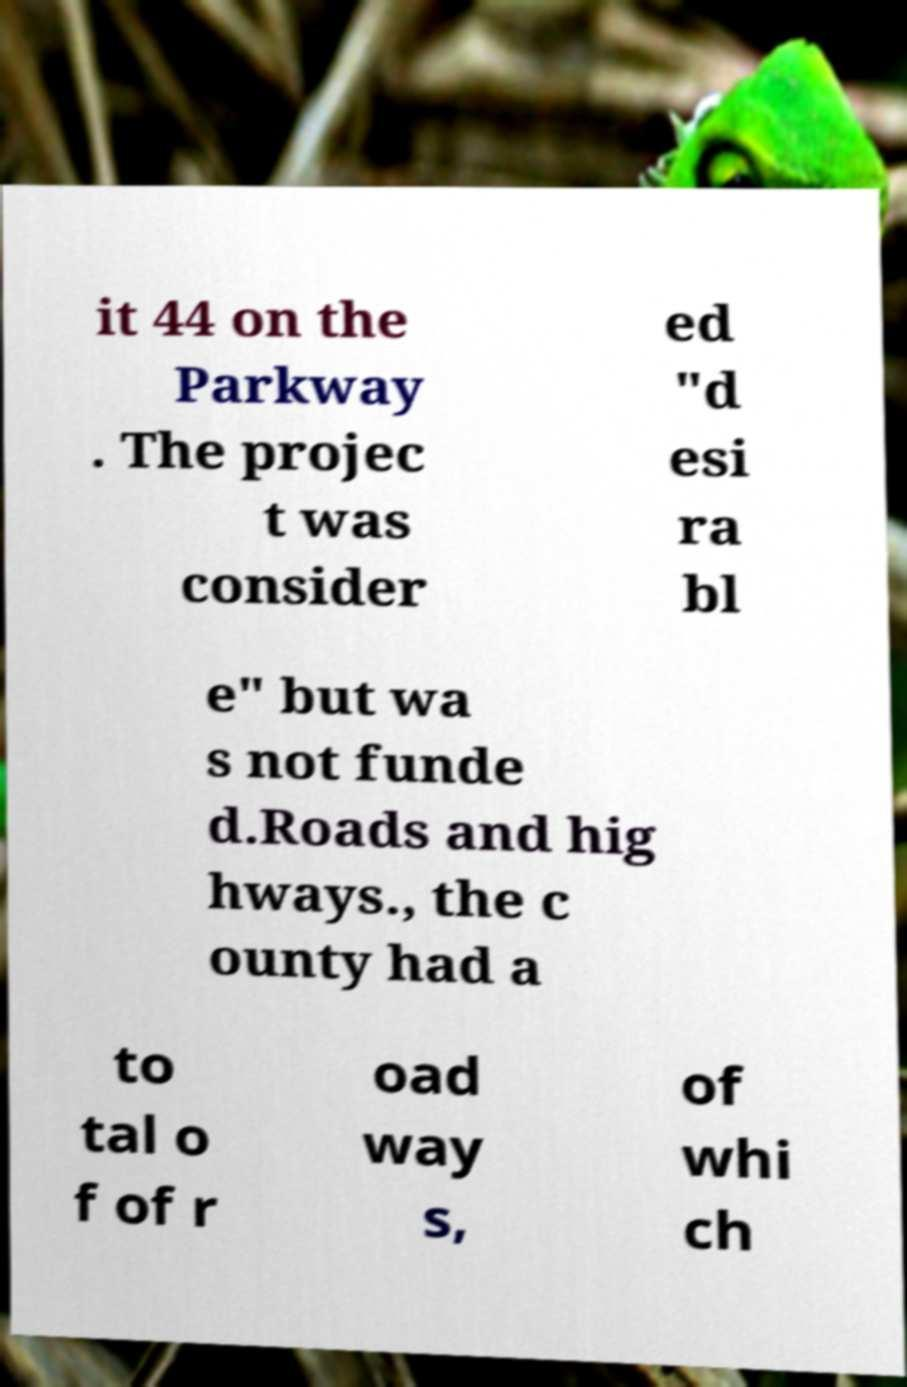Can you read and provide the text displayed in the image?This photo seems to have some interesting text. Can you extract and type it out for me? it 44 on the Parkway . The projec t was consider ed "d esi ra bl e" but wa s not funde d.Roads and hig hways., the c ounty had a to tal o f of r oad way s, of whi ch 